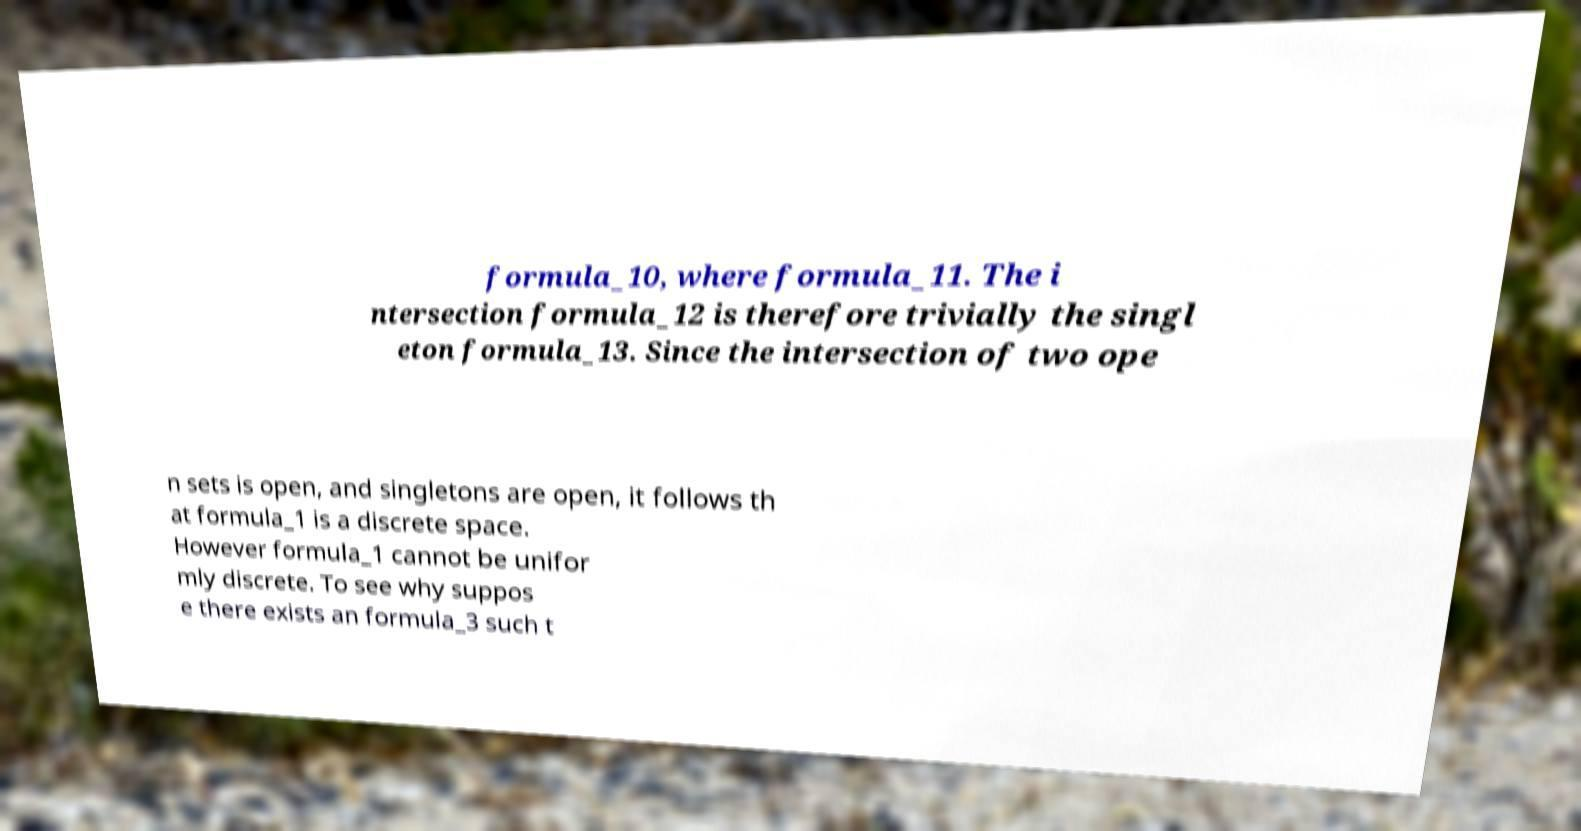Can you read and provide the text displayed in the image?This photo seems to have some interesting text. Can you extract and type it out for me? formula_10, where formula_11. The i ntersection formula_12 is therefore trivially the singl eton formula_13. Since the intersection of two ope n sets is open, and singletons are open, it follows th at formula_1 is a discrete space. However formula_1 cannot be unifor mly discrete. To see why suppos e there exists an formula_3 such t 